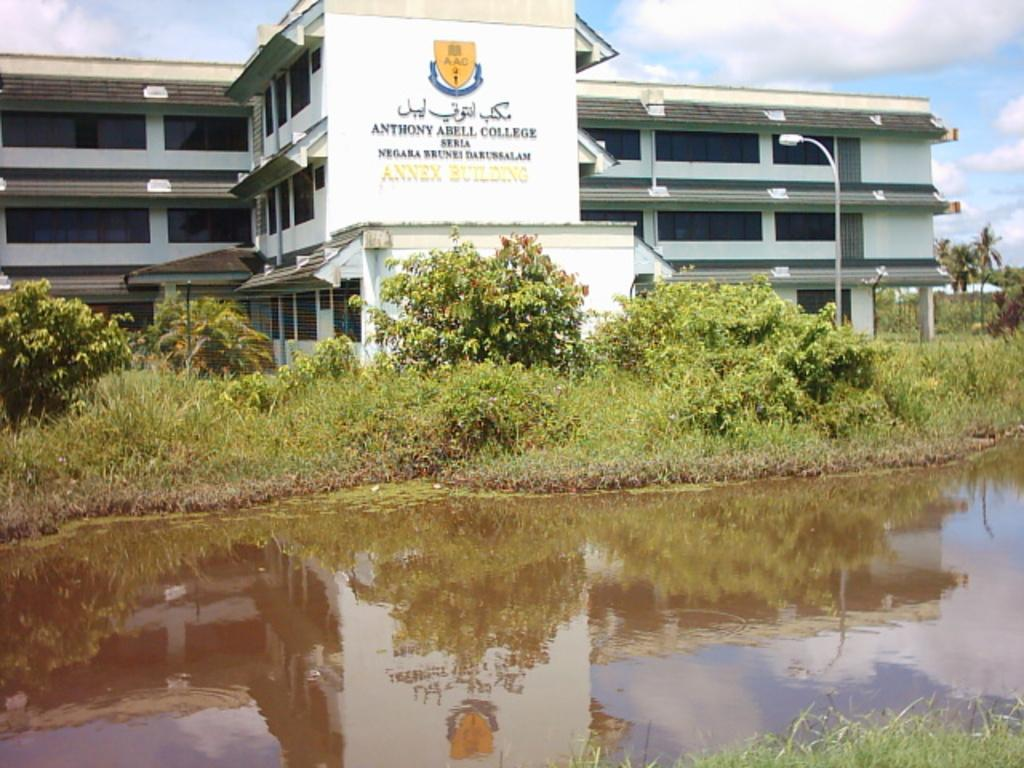Provide a one-sentence caption for the provided image. Anthony Abell College is the building  along the body of water in the picture. 